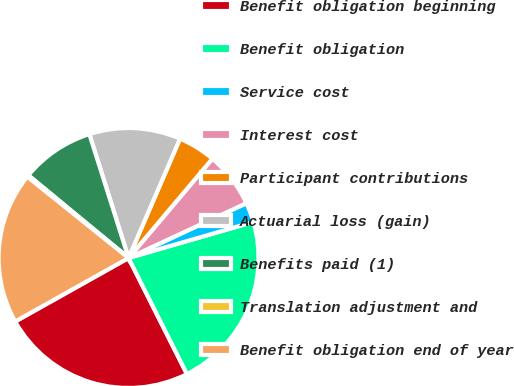Convert chart. <chart><loc_0><loc_0><loc_500><loc_500><pie_chart><fcel>Benefit obligation beginning<fcel>Benefit obligation<fcel>Service cost<fcel>Interest cost<fcel>Participant contributions<fcel>Actuarial loss (gain)<fcel>Benefits paid (1)<fcel>Translation adjustment and<fcel>Benefit obligation end of year<nl><fcel>24.29%<fcel>22.06%<fcel>2.45%<fcel>6.91%<fcel>4.68%<fcel>11.36%<fcel>9.14%<fcel>0.22%<fcel>18.89%<nl></chart> 